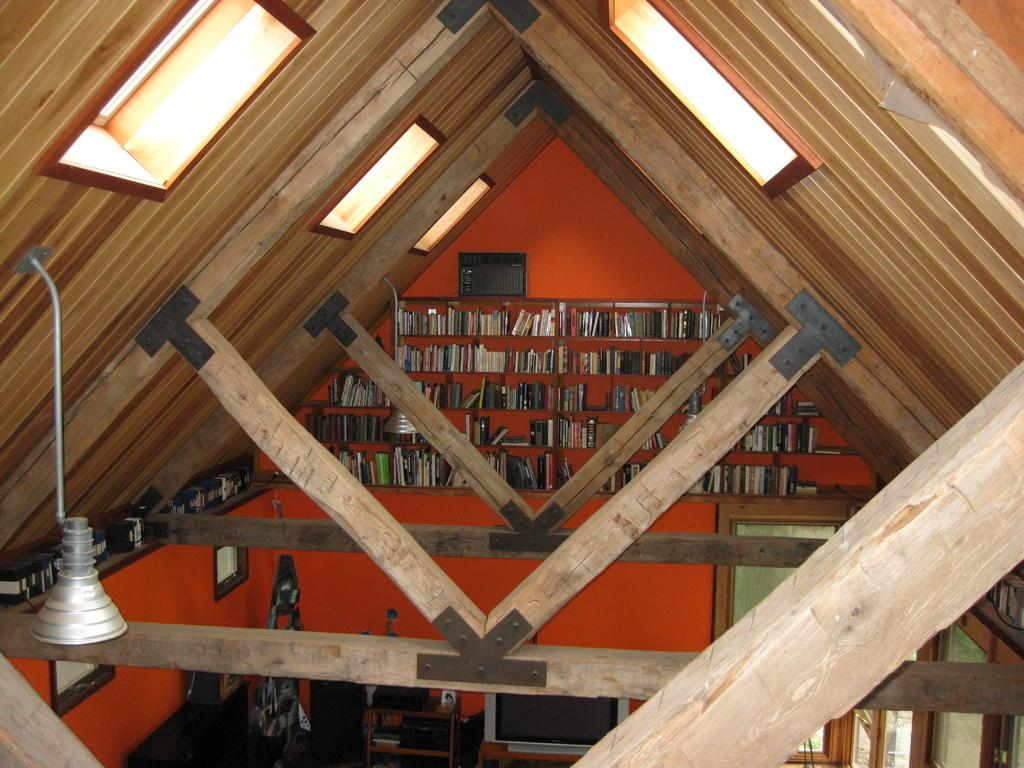What is the main object in the center of the image? There is a beam in the center of the image. What can be seen in the background of the image? There is a bookshelf in the background of the image. What type of fuel is being used by the train in the image? There is no train present in the image, so it is not possible to determine what type of fuel it might be using. 